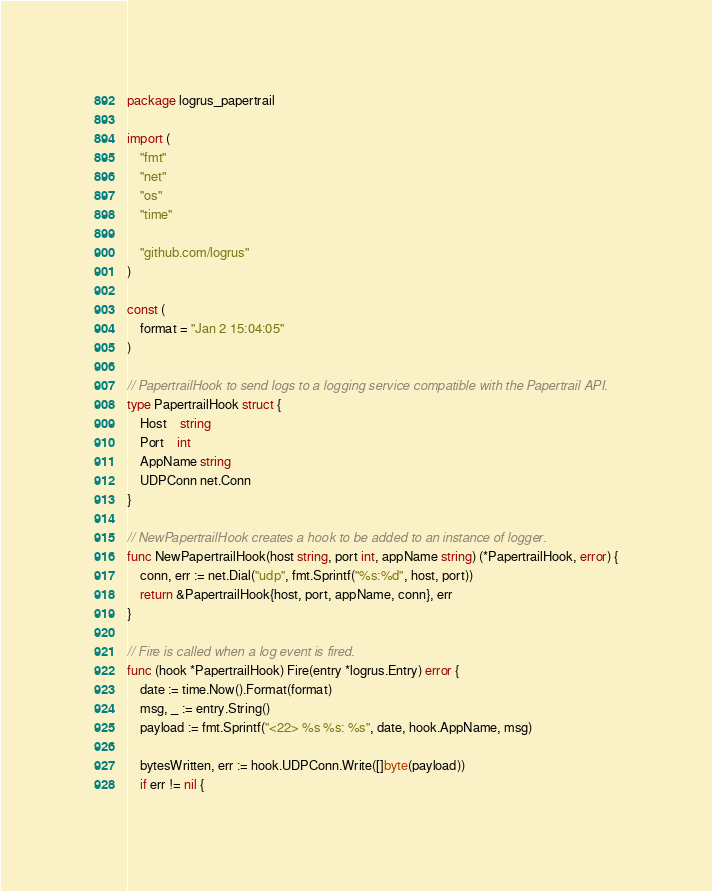Convert code to text. <code><loc_0><loc_0><loc_500><loc_500><_Go_>package logrus_papertrail

import (
	"fmt"
	"net"
	"os"
	"time"

	"github.com/logrus"
)

const (
	format = "Jan 2 15:04:05"
)

// PapertrailHook to send logs to a logging service compatible with the Papertrail API.
type PapertrailHook struct {
	Host    string
	Port    int
	AppName string
	UDPConn net.Conn
}

// NewPapertrailHook creates a hook to be added to an instance of logger.
func NewPapertrailHook(host string, port int, appName string) (*PapertrailHook, error) {
	conn, err := net.Dial("udp", fmt.Sprintf("%s:%d", host, port))
	return &PapertrailHook{host, port, appName, conn}, err
}

// Fire is called when a log event is fired.
func (hook *PapertrailHook) Fire(entry *logrus.Entry) error {
	date := time.Now().Format(format)
	msg, _ := entry.String()
	payload := fmt.Sprintf("<22> %s %s: %s", date, hook.AppName, msg)

	bytesWritten, err := hook.UDPConn.Write([]byte(payload))
	if err != nil {</code> 